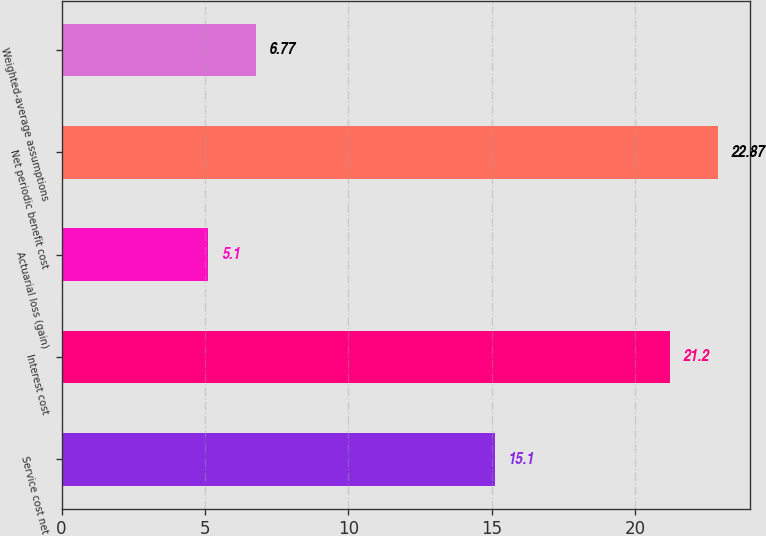Convert chart. <chart><loc_0><loc_0><loc_500><loc_500><bar_chart><fcel>Service cost net<fcel>Interest cost<fcel>Actuarial loss (gain)<fcel>Net periodic benefit cost<fcel>Weighted-average assumptions<nl><fcel>15.1<fcel>21.2<fcel>5.1<fcel>22.87<fcel>6.77<nl></chart> 